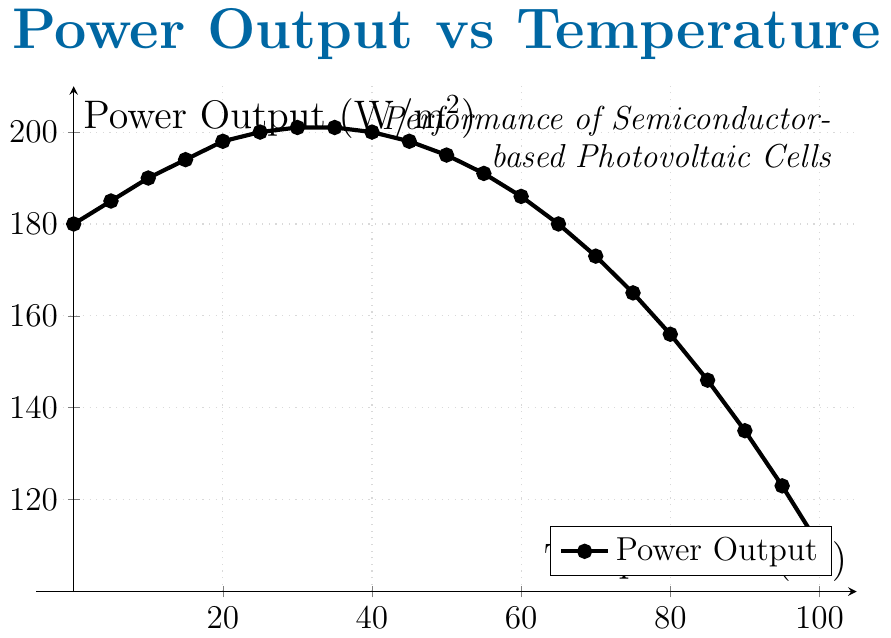What is the power output at 25°C? The power output at 25°C can be directly read from the figure. Look for the point corresponding to 25°C on the x-axis and check its y-value.
Answer: 200 W/m² At what temperature is the maximum power output achieved? To find the maximum power output, identify the highest point on the y-axis and check its corresponding x-value.
Answer: 30-35°C How does the power output change between 20°C and 40°C? Compare the values at 20°C and 40°C. The power output increases from 198 W/m² at 20°C to 201 W/m² at 30-35°C, then it slightly decreases to 200 W/m² at 40°C.
Answer: Slightly increases and then decreases What is the average power output between 0°C and 100°C? Calculate the average of all the power outputs shown on the graph from 0°C to 100°C.
Answer: 174 W/m² (sum of all values divided by number of data points) Compare the power output at 0°C and 100°C. Which one is higher? Check the y-values for 0°C and 100°C. At 0°C, the output is 180 W/m², and at 100°C, it is 110 W/m².
Answer: 0°C What is the rate of decrease in power output from 50°C to 100°C? Calculate the difference in power output between 50°C and 100°C, then divide by the temperature difference. (195-110)/(100-50) = 85/50 = 1.7 W/°C
Answer: 1.7 W/°C Identify the temperature range where the power output is above 190 W/m². Look for the part of the graph where the y-values are above 190 W/m².
Answer: 10°C - 35°C By how much does the power output decrease from 25°C to 85°C? Calculate the difference in power output at 25°C and 85°C. 200 W/m² - 146 W/m² = 54 W/m²
Answer: 54 W/m² At what temperature does the power output first drop below 150 W/m²? Identify the first x-value where the y-value is less than 150 W/m².
Answer: 85°C Which temperature interval shows the steepest decline in power output? Examine the slopes of the various segments of the graph to determine where the decline is most rapid.
Answer: 75°C to 95°C 